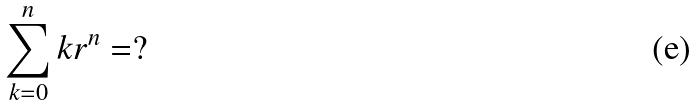<formula> <loc_0><loc_0><loc_500><loc_500>\sum _ { k = 0 } ^ { n } k r ^ { n } = ?</formula> 